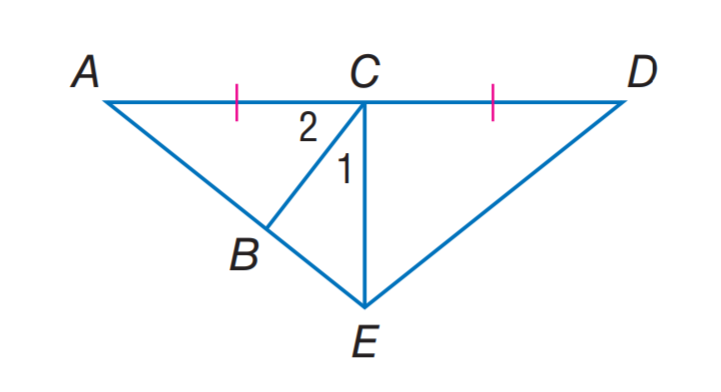Question: If E C is an altitude of \triangle A E D, m \angle 1 = 2 x + 7, and m \angle 2 = 3 x + 13, find m \angle 2.
Choices:
A. 25
B. 35
C. 45
D. 55
Answer with the letter. Answer: D Question: If E C is an altitude of \triangle A E D, m \angle 1 = 2 x + 7, and m \angle 2 = 3 x + 13, find m \angle 1.
Choices:
A. 25
B. 35
C. 45
D. 55
Answer with the letter. Answer: B 